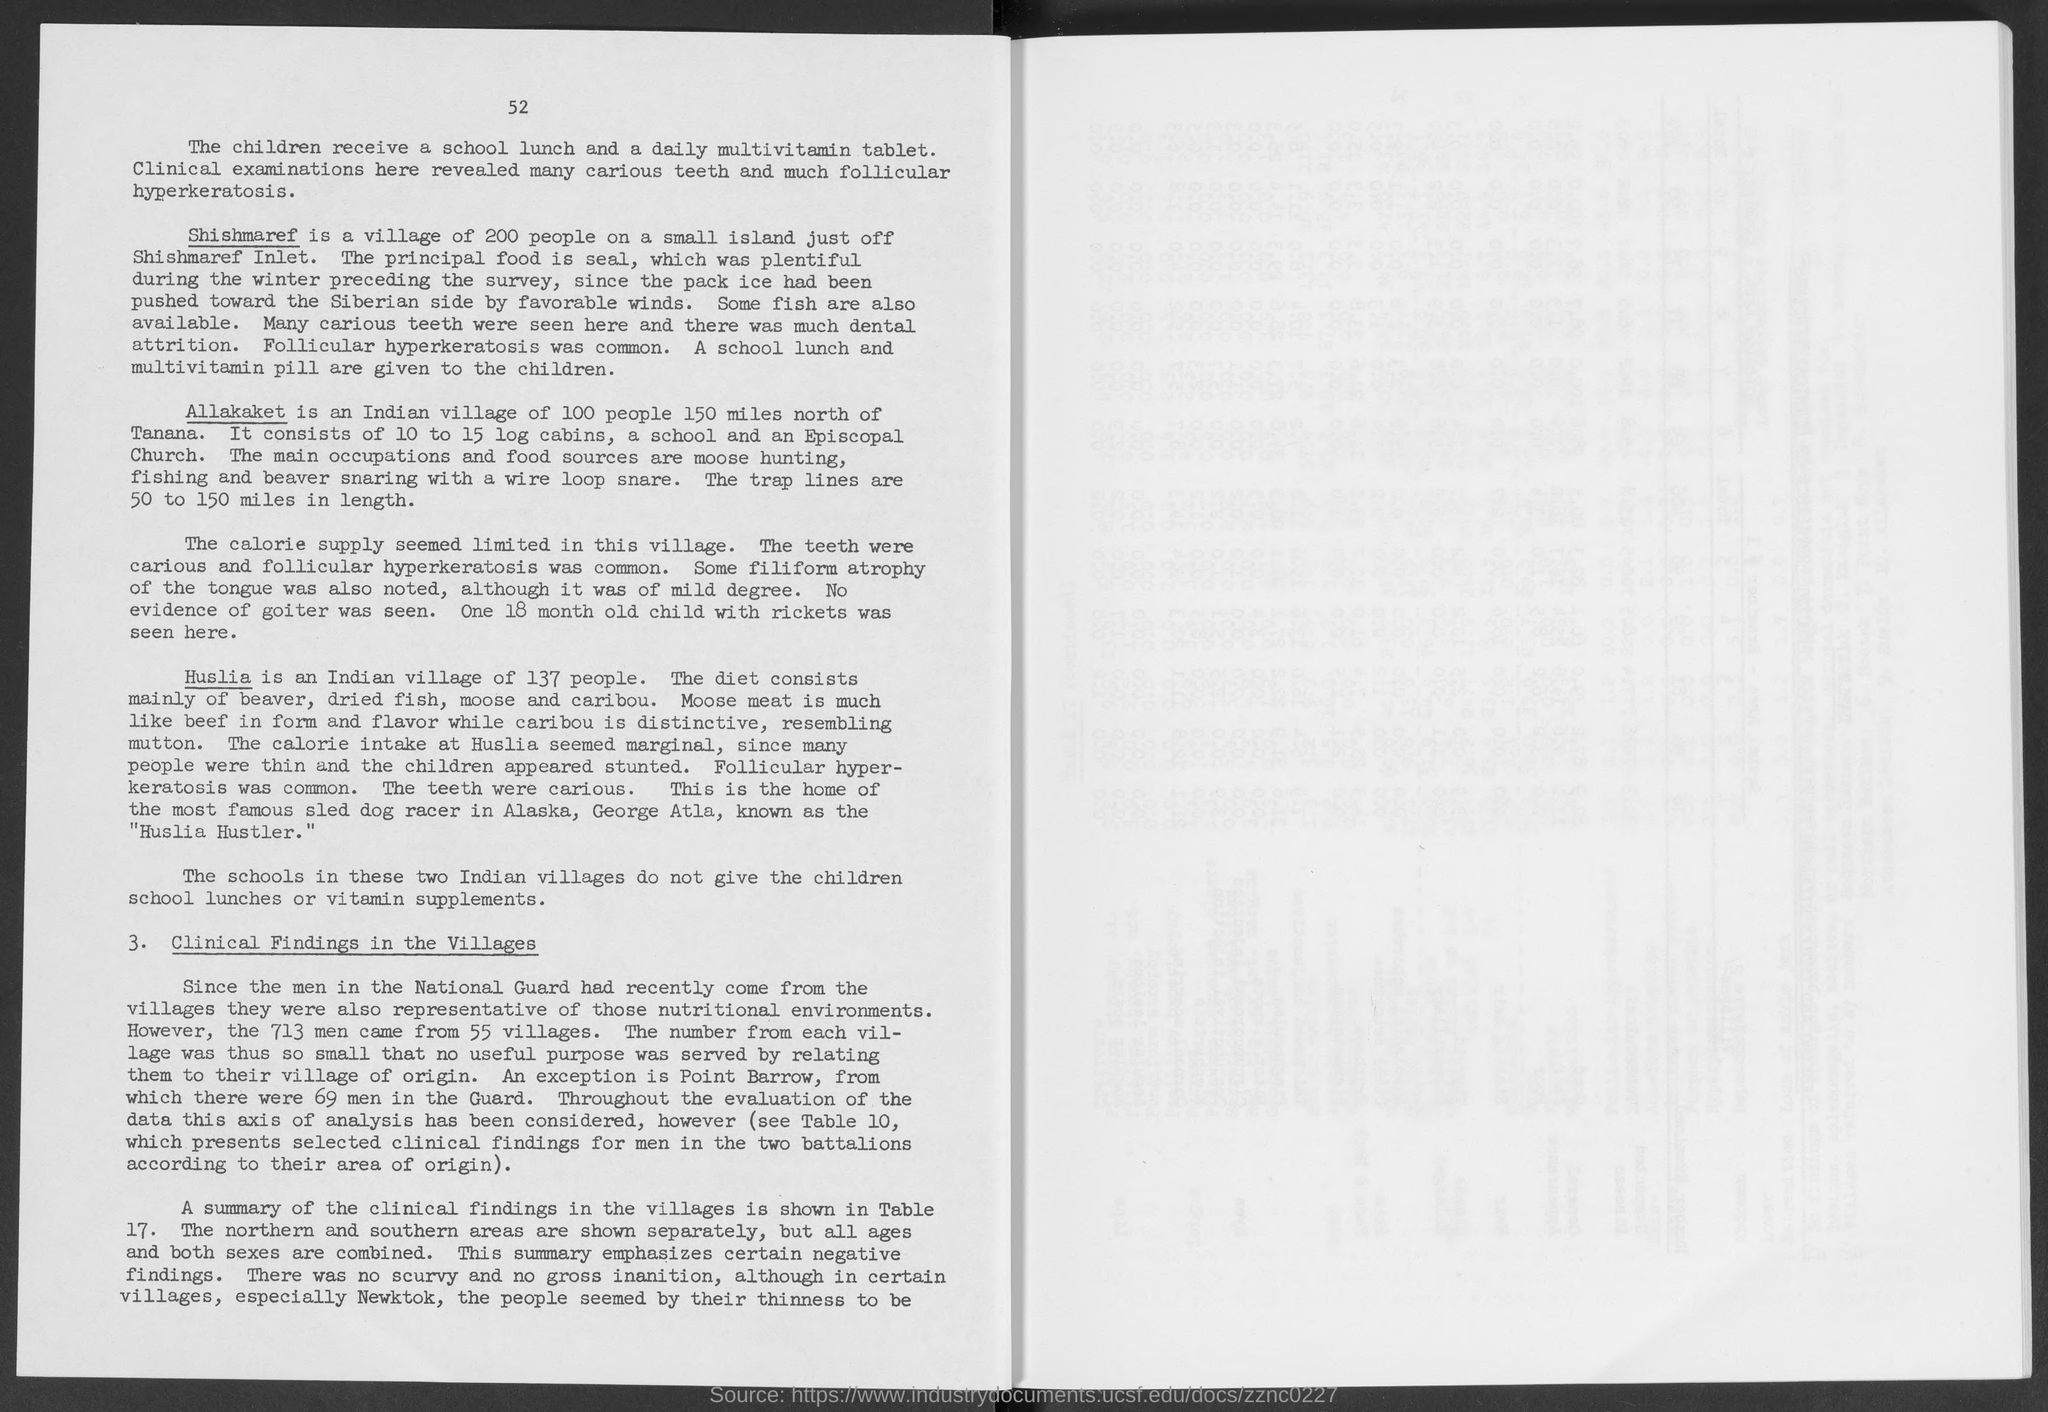Which is an Indian village of 137 people?
Offer a very short reply. Huslia. Which is a village of 200 people on a small island just off Shishmaref Inlet?
Give a very brief answer. Shishmaref. Which is an Indian village of 100 people 150 miles north of Tanana?
Provide a short and direct response. Allakaket. 